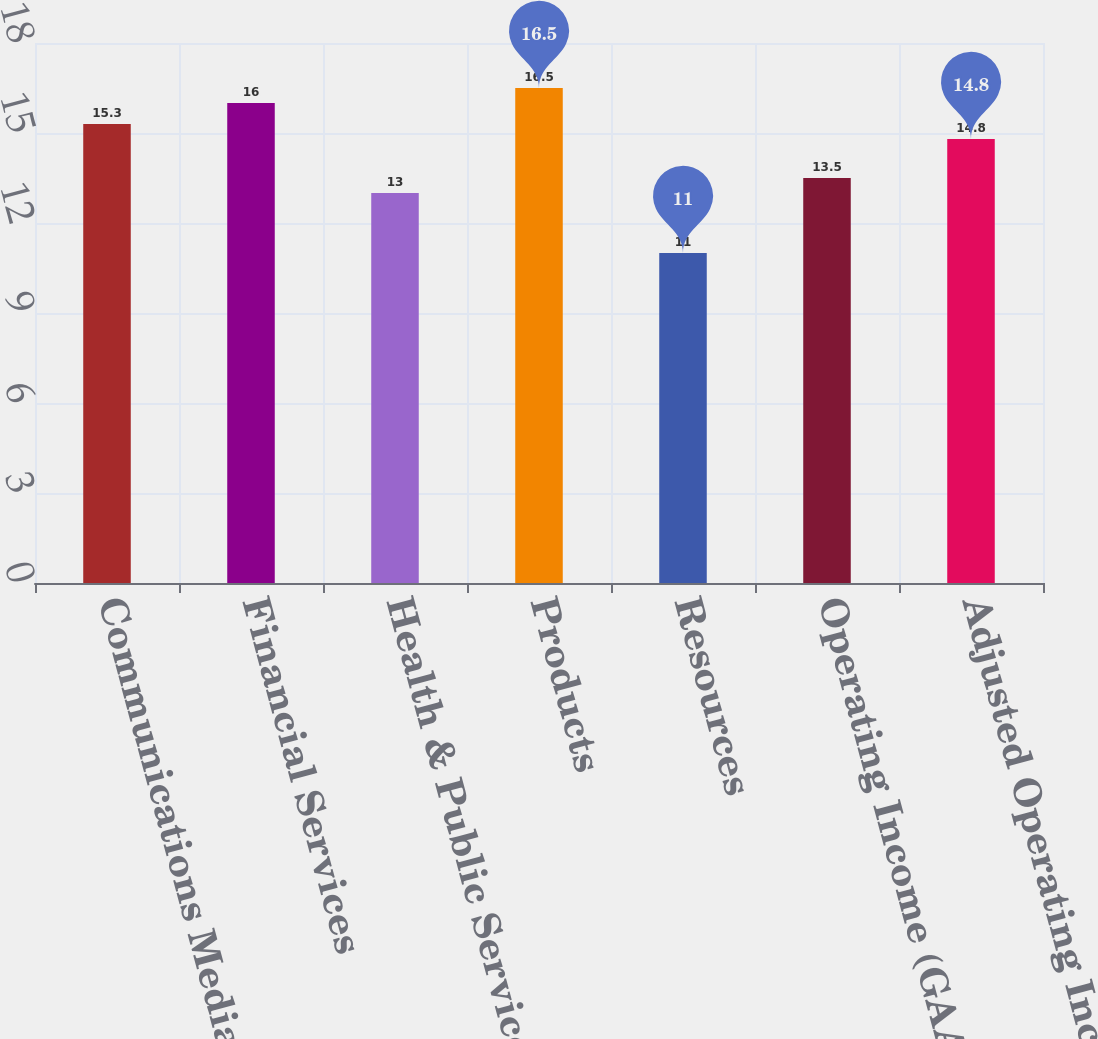<chart> <loc_0><loc_0><loc_500><loc_500><bar_chart><fcel>Communications Media &<fcel>Financial Services<fcel>Health & Public Service<fcel>Products<fcel>Resources<fcel>Operating Income (GAAP)<fcel>Adjusted Operating Income<nl><fcel>15.3<fcel>16<fcel>13<fcel>16.5<fcel>11<fcel>13.5<fcel>14.8<nl></chart> 